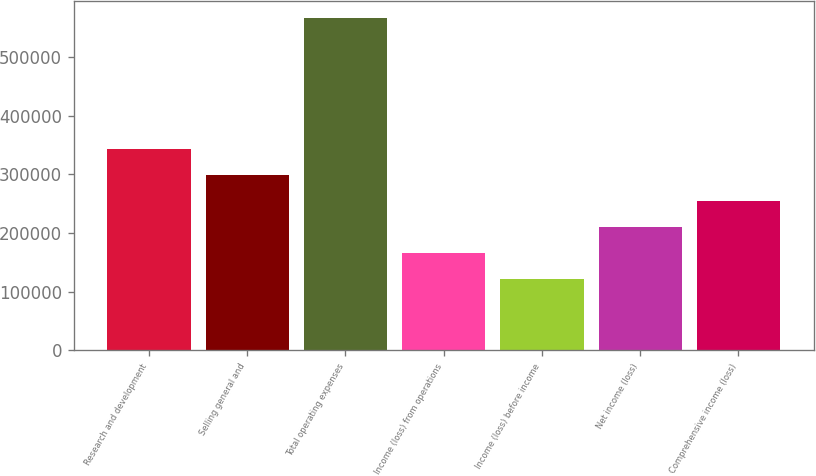<chart> <loc_0><loc_0><loc_500><loc_500><bar_chart><fcel>Research and development<fcel>Selling general and<fcel>Total operating expenses<fcel>Income (loss) from operations<fcel>Income (loss) before income<fcel>Net income (loss)<fcel>Comprehensive income (loss)<nl><fcel>344042<fcel>299481<fcel>566842<fcel>165801<fcel>121241<fcel>210361<fcel>254921<nl></chart> 